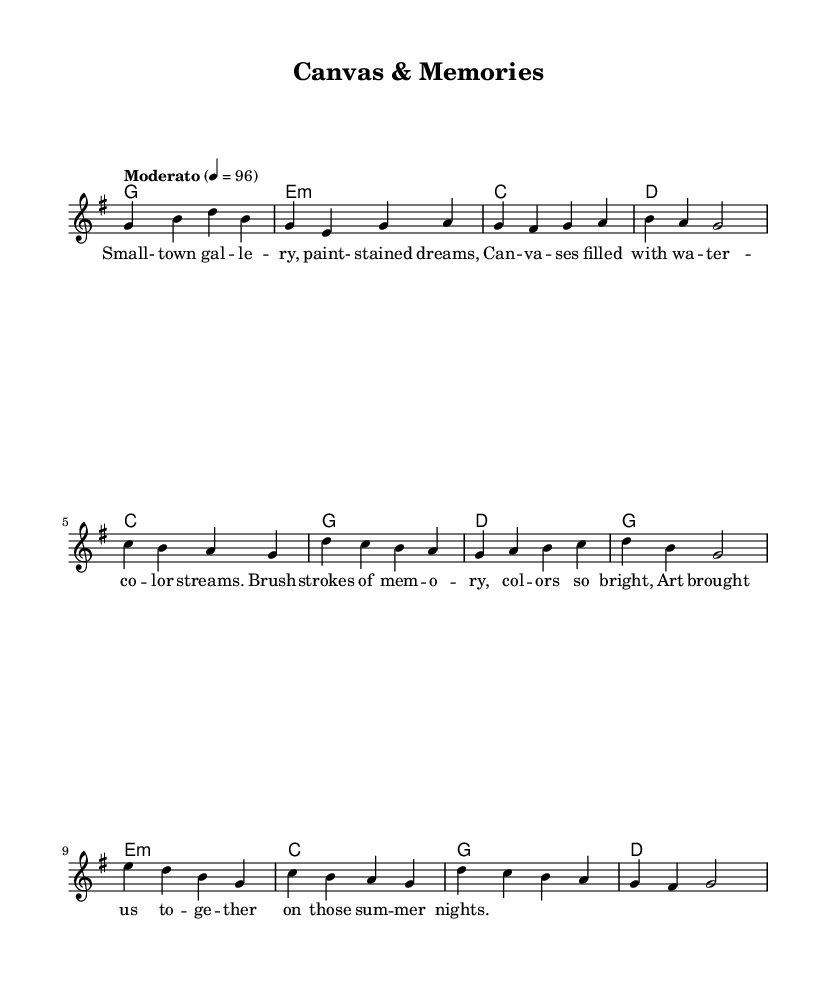What is the key signature of this music? The key signature is G major, which has one sharp (F#).
Answer: G major What is the time signature of the music? The time signature is 4/4, meaning there are four beats in each measure.
Answer: 4/4 What tempo is indicated for this piece? The tempo marked is "Moderato," which typically suggests a moderate pace around 96 beats per minute.
Answer: Moderato How many measures are in the verse section? The verse section consists of four measures, as indicated by the notation.
Answer: 4 Which chord follows the melody line at the beginning of the chorus? The chord following the melody line at the beginning of the chorus is C major.
Answer: C What type of art is referenced in the lyrics of the song? The lyrics reference watercolor art, suggesting a nostalgic feeling associated with transient creative moments.
Answer: Watercolor How is the community's creativity depicted in the chorus? The chorus depicts the community's creativity through shared art experiences and vibrant memories, emphasizing togetherness during summer nights.
Answer: Togetherness 